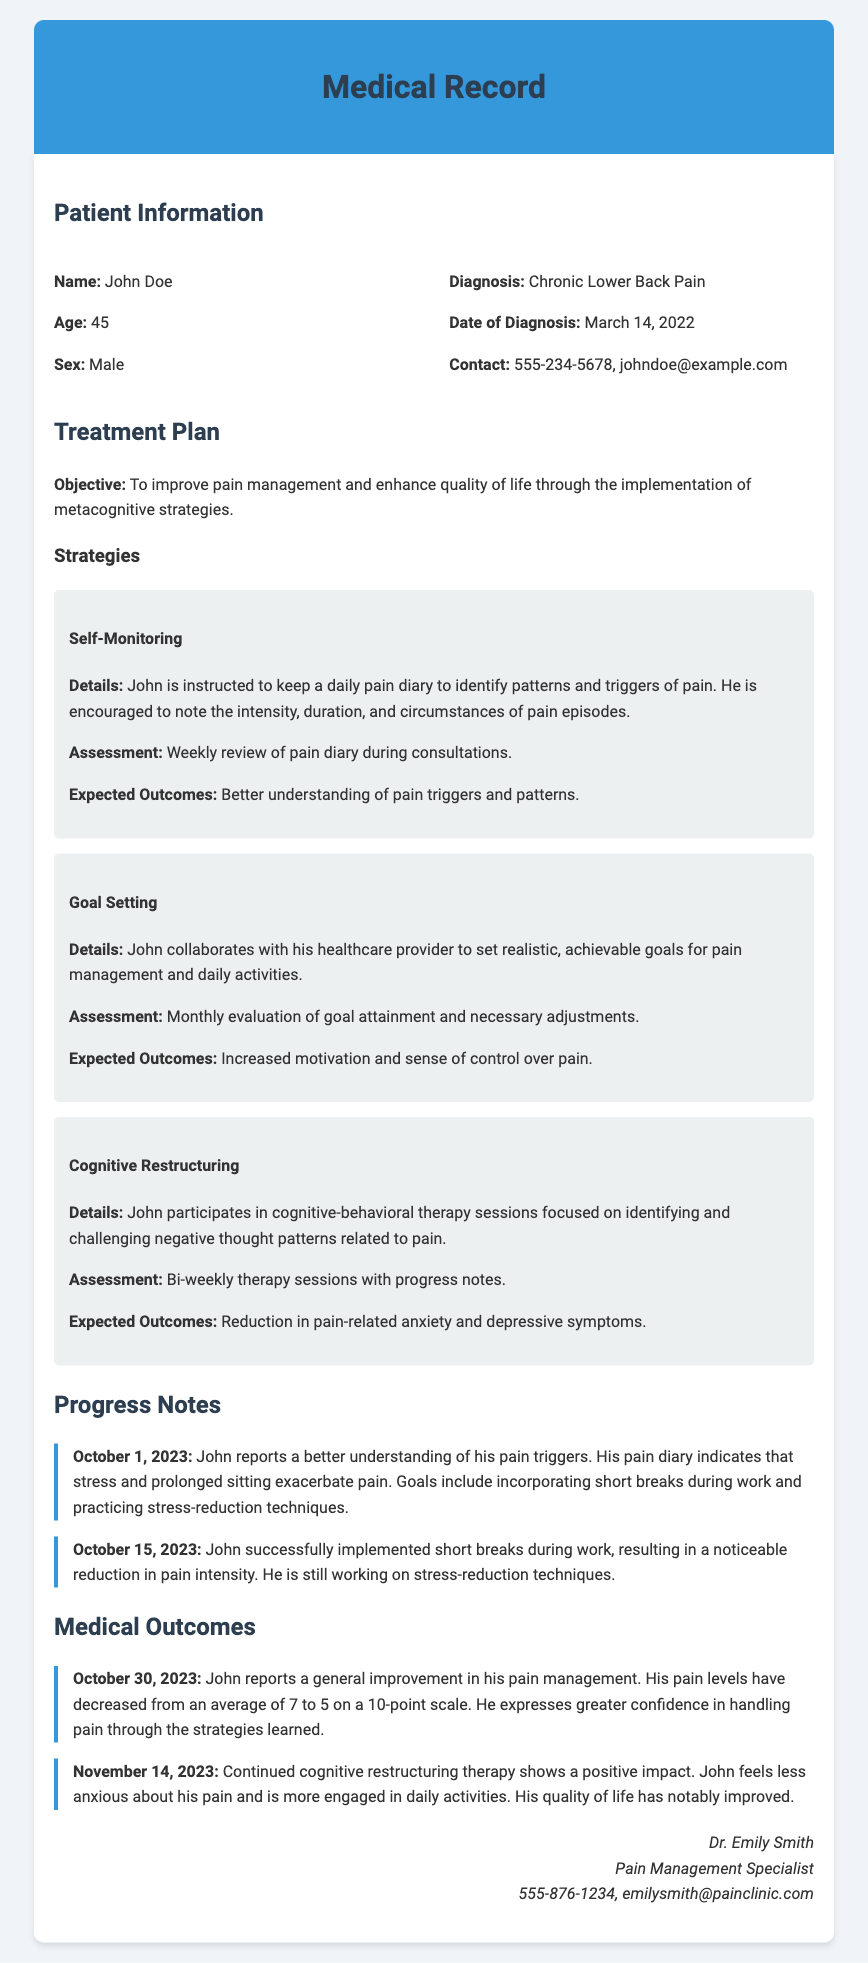What is the patient's name? The patient's name is stated in the document as John Doe.
Answer: John Doe What is the diagnosis? The diagnosis provided in the document is Chronic Lower Back Pain.
Answer: Chronic Lower Back Pain What date was the diagnosis made? The document specifies the date of diagnosis as March 14, 2022.
Answer: March 14, 2022 What strategy involves keeping a daily pain diary? The strategy involving keeping a daily pain diary is Self-Monitoring.
Answer: Self-Monitoring What was John's average pain level on October 30, 2023? The document mentions that John's average pain level decreased to 5 on a 10-point scale on October 30, 2023.
Answer: 5 Which metacognitive strategy focuses on changing negative thought patterns? The metacognitive strategy that focuses on changing negative thought patterns is Cognitive Restructuring.
Answer: Cognitive Restructuring What are the expected outcomes of the Goal Setting strategy? The expected outcomes listed for the Goal Setting strategy include increased motivation and sense of control over pain.
Answer: Increased motivation and sense of control over pain How often are progress notes reviewed? Progress notes are reviewed during consultations, which are weekly for the Self-Monitoring strategy.
Answer: Weekly What professional is responsible for John's treatment? The document states that Dr. Emily Smith is responsible for John's treatment as his Pain Management Specialist.
Answer: Dr. Emily Smith 